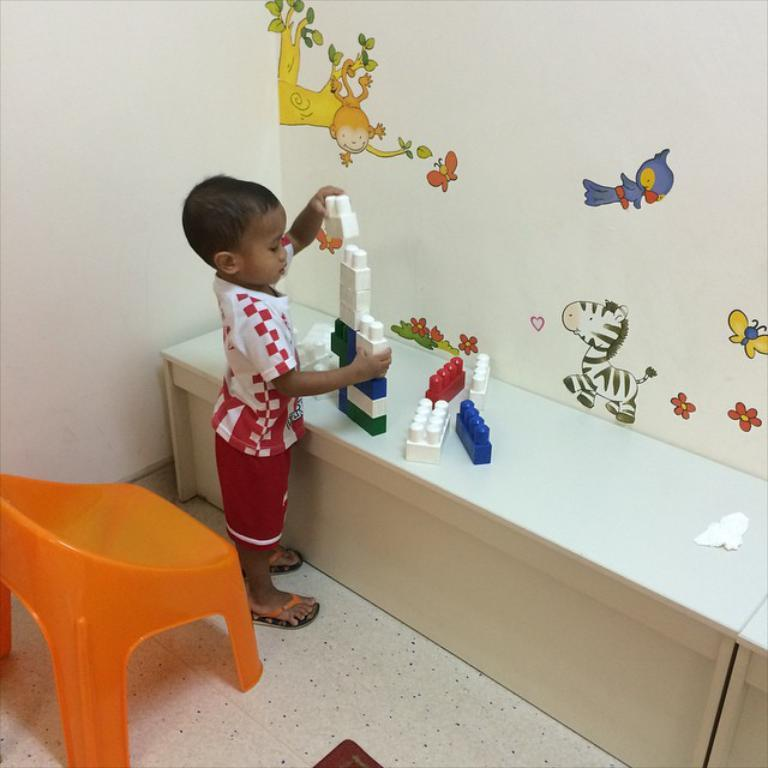What is the kid doing in the image? The kid is playing with toys in the image. Where is the chair located in the image? The chair is on the left side of the image. What is depicted on the wall in the image? The wall is painted with animals. What piece of furniture is in the center of the image? There is a desk in the center of the image. What is the acoustics like in the room depicted in the image? The provided facts do not give any information about the acoustics in the room, so it cannot be determined from the image. 